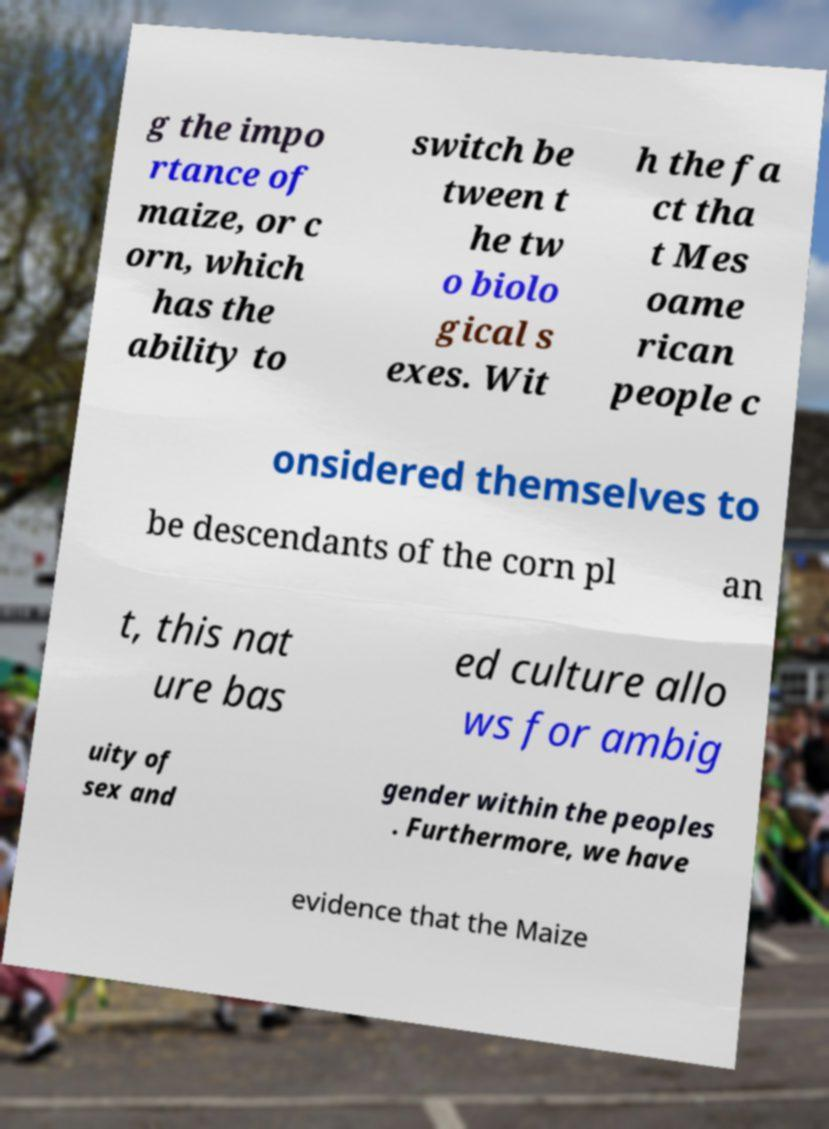For documentation purposes, I need the text within this image transcribed. Could you provide that? g the impo rtance of maize, or c orn, which has the ability to switch be tween t he tw o biolo gical s exes. Wit h the fa ct tha t Mes oame rican people c onsidered themselves to be descendants of the corn pl an t, this nat ure bas ed culture allo ws for ambig uity of sex and gender within the peoples . Furthermore, we have evidence that the Maize 